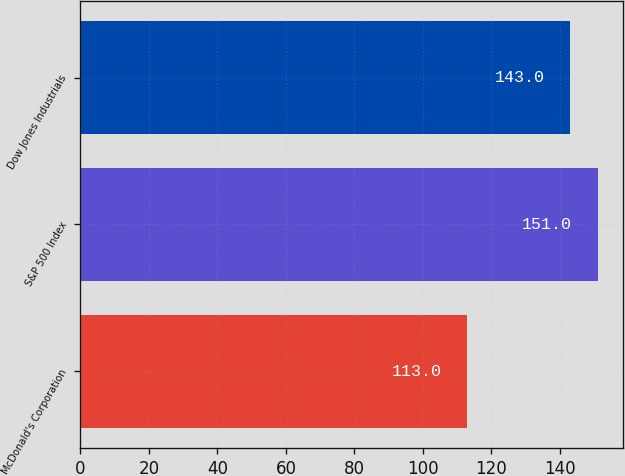<chart> <loc_0><loc_0><loc_500><loc_500><bar_chart><fcel>McDonald's Corporation<fcel>S&P 500 Index<fcel>Dow Jones Industrials<nl><fcel>113<fcel>151<fcel>143<nl></chart> 